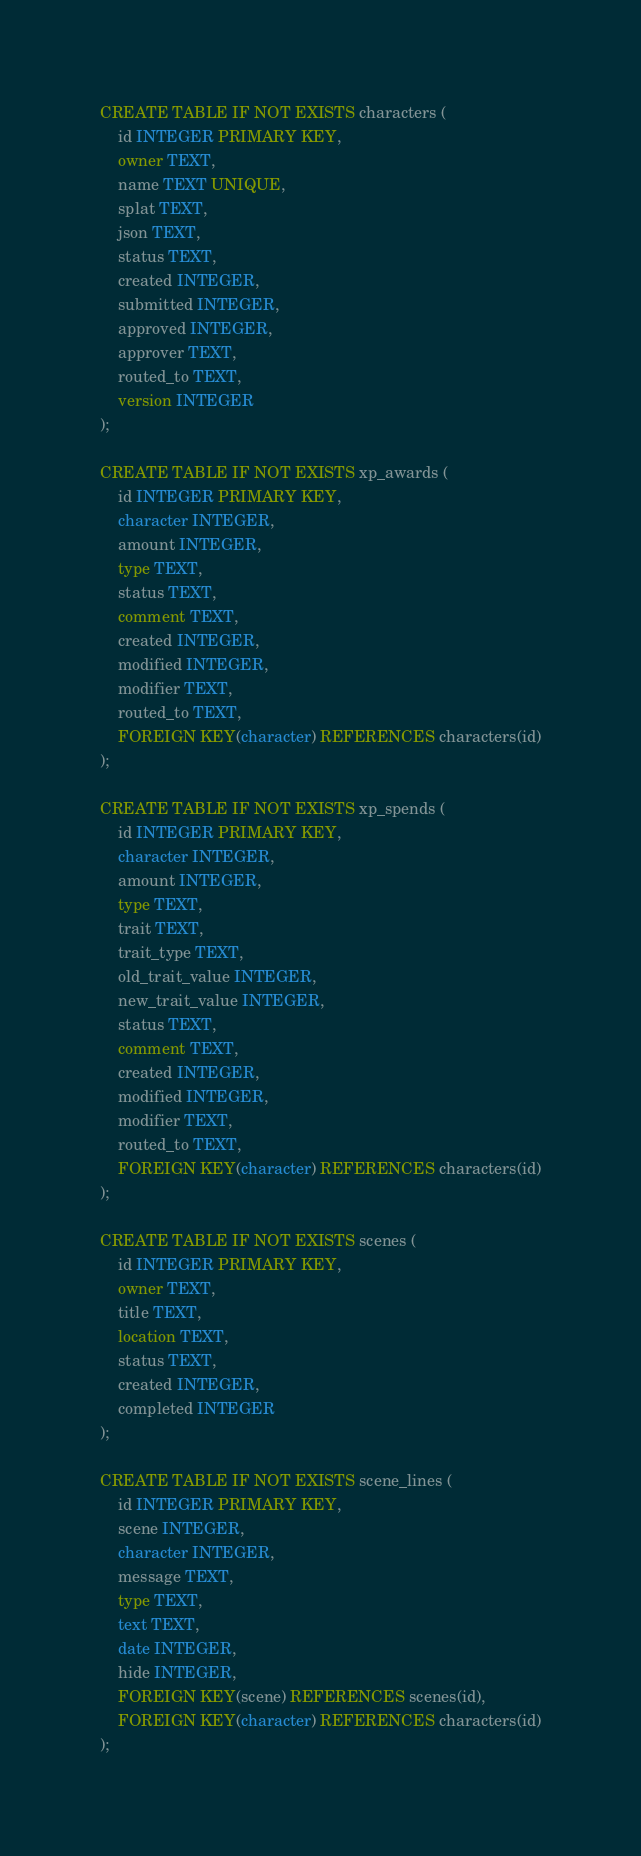Convert code to text. <code><loc_0><loc_0><loc_500><loc_500><_SQL_>CREATE TABLE IF NOT EXISTS characters (
	id INTEGER PRIMARY KEY,
	owner TEXT,
	name TEXT UNIQUE,
	splat TEXT,
	json TEXT,
	status TEXT,
	created INTEGER,
	submitted INTEGER,
	approved INTEGER,
	approver TEXT,
	routed_to TEXT,
	version INTEGER
);

CREATE TABLE IF NOT EXISTS xp_awards (
	id INTEGER PRIMARY KEY,
	character INTEGER,
	amount INTEGER,
	type TEXT,
	status TEXT,
	comment TEXT,
	created INTEGER,
	modified INTEGER,
	modifier TEXT,
	routed_to TEXT,
	FOREIGN KEY(character) REFERENCES characters(id)
);

CREATE TABLE IF NOT EXISTS xp_spends (
	id INTEGER PRIMARY KEY,
	character INTEGER,
	amount INTEGER,
	type TEXT,
	trait TEXT,
	trait_type TEXT,
	old_trait_value INTEGER,
	new_trait_value INTEGER,
	status TEXT,
	comment TEXT,
	created INTEGER,
	modified INTEGER,
	modifier TEXT,
	routed_to TEXT,
	FOREIGN KEY(character) REFERENCES characters(id)
);

CREATE TABLE IF NOT EXISTS scenes (
	id INTEGER PRIMARY KEY,
	owner TEXT,
	title TEXT,
	location TEXT,
	status TEXT,
	created INTEGER,
	completed INTEGER
);

CREATE TABLE IF NOT EXISTS scene_lines (
	id INTEGER PRIMARY KEY,
	scene INTEGER,
	character INTEGER,
	message TEXT,
	type TEXT,
	text TEXT,
	date INTEGER,
	hide INTEGER,
	FOREIGN KEY(scene) REFERENCES scenes(id),
	FOREIGN KEY(character) REFERENCES characters(id)
);</code> 